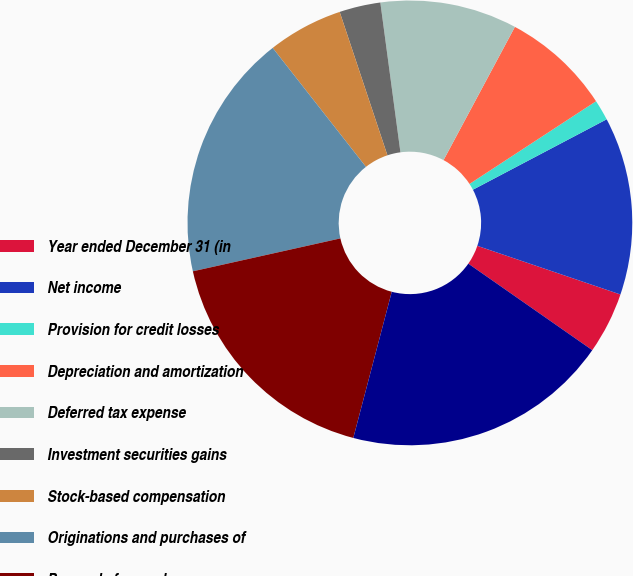Convert chart to OTSL. <chart><loc_0><loc_0><loc_500><loc_500><pie_chart><fcel>Year ended December 31 (in<fcel>Net income<fcel>Provision for credit losses<fcel>Depreciation and amortization<fcel>Deferred tax expense<fcel>Investment securities gains<fcel>Stock-based compensation<fcel>Originations and purchases of<fcel>Proceeds from sales<fcel>Trading assets<nl><fcel>4.48%<fcel>12.93%<fcel>1.5%<fcel>7.96%<fcel>9.95%<fcel>2.99%<fcel>5.47%<fcel>17.91%<fcel>17.41%<fcel>19.4%<nl></chart> 